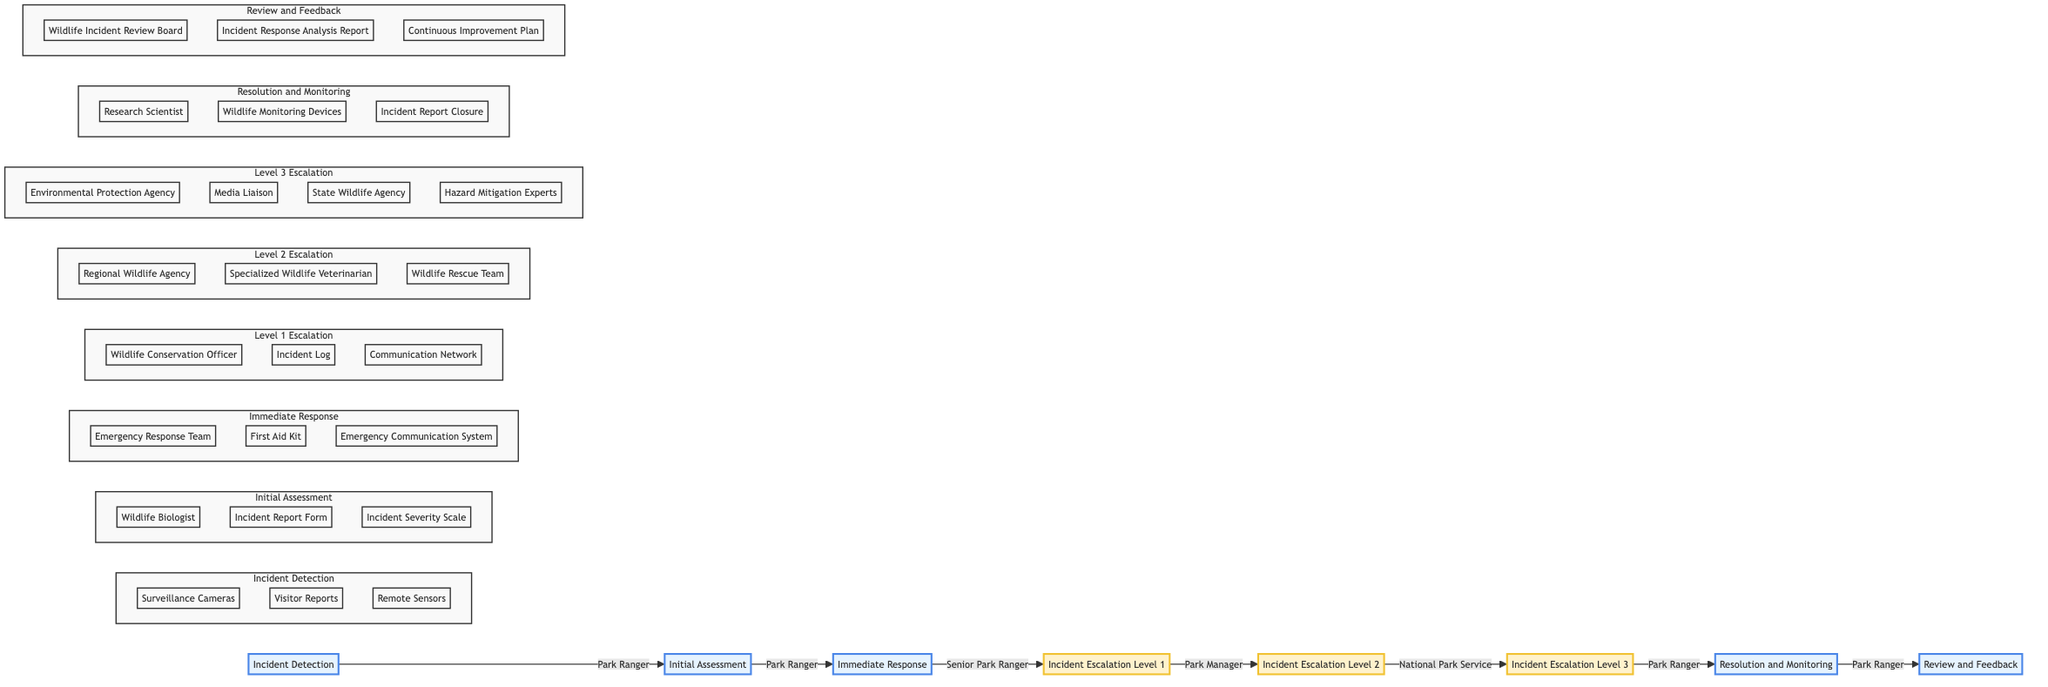What is the first phase of the Wildlife Incident Response Process? The first phase is labeled as "Incident Detection" in the diagram. This can be directly seen from the starting node of the flowchart.
Answer: Incident Detection How many escalation levels are present in the diagram? There are three escalation levels depicted: Level 1, Level 2, and Level 3. Counting these escalation nodes in the flowchart gives us the total.
Answer: Three Which entity is involved in the Immediate Response phase? The Immediate Response phase includes the "Emergency Response Team" as one of the entities. This is indicated directly within the Immediate Response section of the diagram.
Answer: Emergency Response Team What is the purpose of the Resolution and Monitoring phase? The purpose of the Resolution and Monitoring phase is to "resolve the incident and monitor the situation to prevent recurrence." This description is provided in the corresponding node in the diagram.
Answer: Resolve the incident and monitor the situation to prevent recurrence Which entity escalates the incident to Level 2? The entity responsible for escalating the incident to Level 2 is the "Park Manager," as shown in the connection from Level 1 Escalation to Level 2 Escalation in the flowchart.
Answer: Park Manager What happens immediately after the Immediate Response phase? After the Immediate Response phase, the flowchart indicates the next phase is "Incident Escalation Level 1." This is sequentially shown in the diagram linking C (Immediate Response) to D (Incident Escalation Level 1).
Answer: Incident Escalation Level 1 Name one external agency involved in Level 3 Escalation. One external agency involved in Level 3 Escalation is the "Environmental Protection Agency," which is listed as one of the entities in that phase of the diagram.
Answer: Environmental Protection Agency What is the connection type between the Initial Assessment and Immediate Response phases? The connection type between the Initial Assessment and Immediate Response phases is a direct flow indicated by an arrow connecting B (Initial Assessment) to C (Immediate Response). This shows the process flows directly from one phase to the next.
Answer: Direct flow Who is responsible for the Review and Feedback phase? The "Park Ranger" is responsible for the Review and Feedback phase. This can be seen in the node representation indicating that they are involved in this phase.
Answer: Park Ranger 